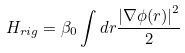Convert formula to latex. <formula><loc_0><loc_0><loc_500><loc_500>H _ { r i g } = \beta _ { 0 } \int d { r } \frac { \left | \nabla \phi ( { r } ) \right | ^ { 2 } } 2</formula> 